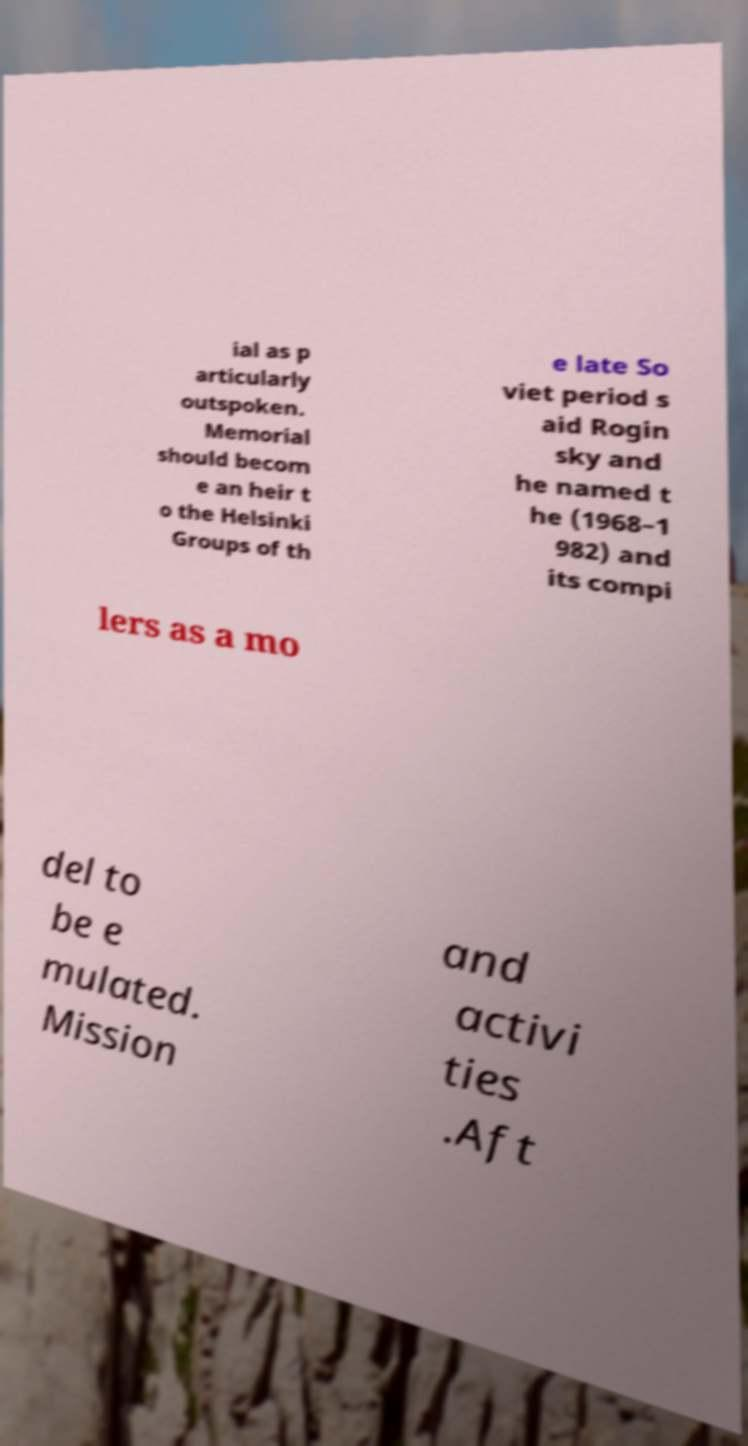Please identify and transcribe the text found in this image. ial as p articularly outspoken. Memorial should becom e an heir t o the Helsinki Groups of th e late So viet period s aid Rogin sky and he named t he (1968–1 982) and its compi lers as a mo del to be e mulated. Mission and activi ties .Aft 